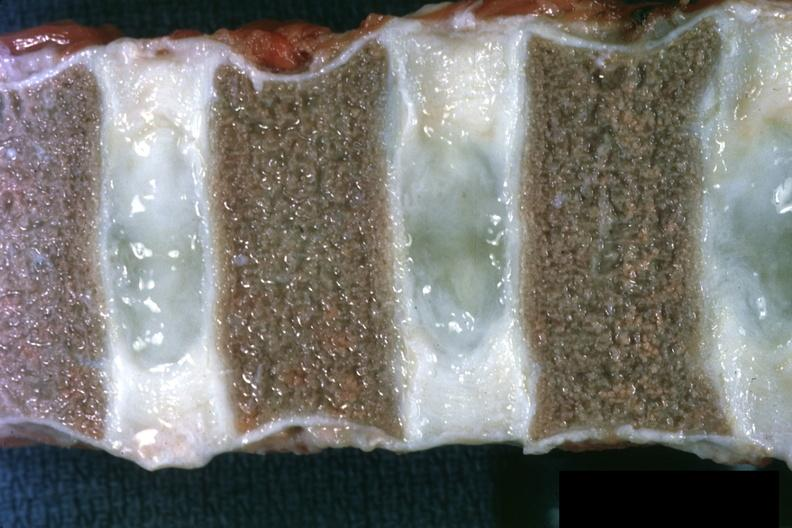s cardiovascular present?
Answer the question using a single word or phrase. No 